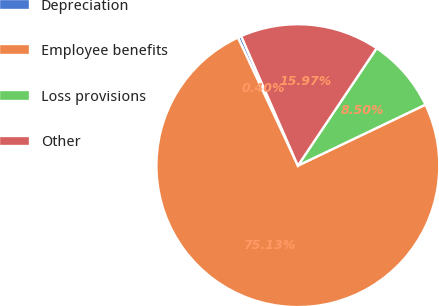Convert chart to OTSL. <chart><loc_0><loc_0><loc_500><loc_500><pie_chart><fcel>Depreciation<fcel>Employee benefits<fcel>Loss provisions<fcel>Other<nl><fcel>0.4%<fcel>75.14%<fcel>8.5%<fcel>15.97%<nl></chart> 